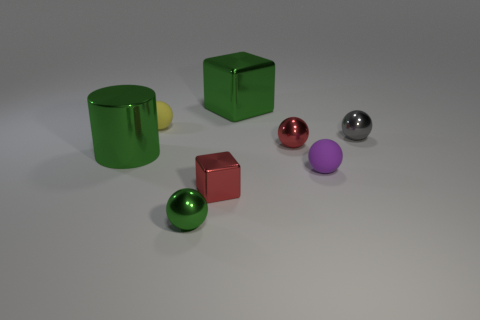How many other things are the same shape as the tiny green shiny object?
Keep it short and to the point. 4. What number of gray things are matte cylinders or matte spheres?
Provide a succinct answer. 0. What is the material of the cube that is right of the tiny red metal thing on the left side of the large green cube?
Provide a short and direct response. Metal. Do the tiny green object and the yellow rubber thing have the same shape?
Offer a very short reply. Yes. There is a metallic cube that is the same size as the gray ball; what is its color?
Make the answer very short. Red. Is there a small sphere of the same color as the large cylinder?
Your answer should be compact. Yes. Are there any large red matte objects?
Keep it short and to the point. No. Are the tiny object that is behind the tiny gray ball and the tiny purple sphere made of the same material?
Your answer should be compact. Yes. There is a metallic cube that is the same color as the shiny cylinder; what is its size?
Make the answer very short. Large. What number of gray balls have the same size as the green block?
Offer a very short reply. 0. 